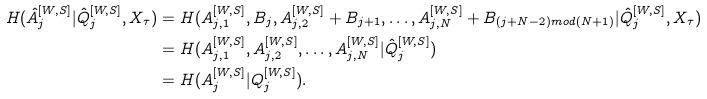Convert formula to latex. <formula><loc_0><loc_0><loc_500><loc_500>H ( \hat { A } _ { j } ^ { [ W , S ] } | \hat { Q } _ { j } ^ { [ W , S ] } , X _ { \tau } ) & = H ( A _ { j , 1 } ^ { [ W , S ] } , B _ { j } , A _ { j , 2 } ^ { [ W , S ] } + B _ { j + 1 } , \dots , A _ { j , N } ^ { [ W , S ] } + B _ { ( j + N - 2 ) m o d ( N + 1 ) } | \hat { Q } _ { j } ^ { [ W , S ] } , X _ { \tau } ) \\ & = H ( A _ { j , 1 } ^ { [ W , S ] } , A _ { j , 2 } ^ { [ W , S ] } , \dots , A _ { j , N } ^ { [ W , S ] } | \hat { Q } _ { j } ^ { [ W , S ] } ) \\ & = H ( A _ { j } ^ { [ W , S ] } | Q _ { j } ^ { [ W , S ] } ) .</formula> 